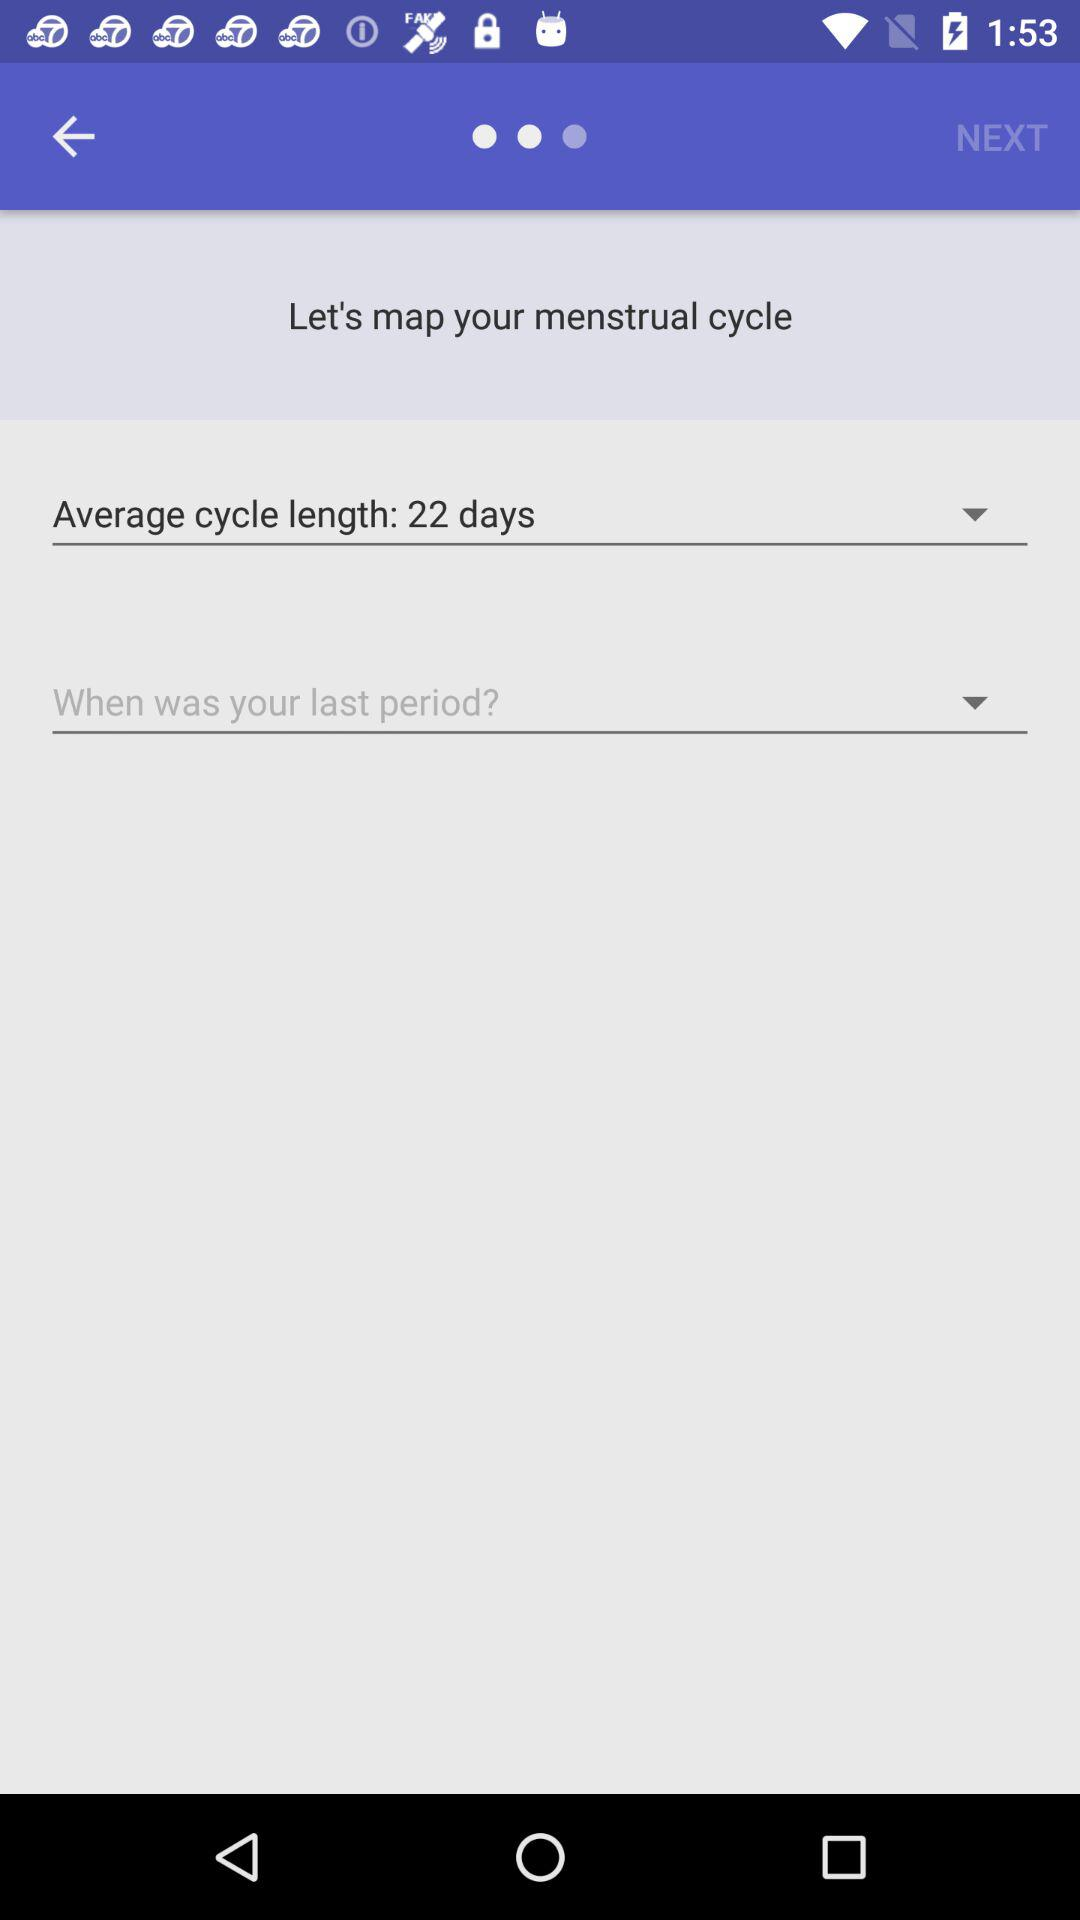What is the "Average cycle length"? The average cycle length is 22 days. 